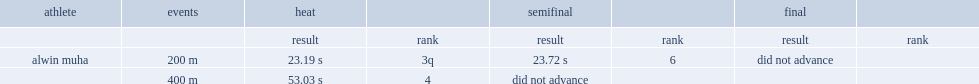What was the result that alwin muha got in the heat of the 400m event? 53.03 s. 